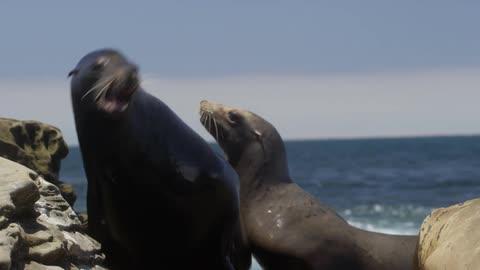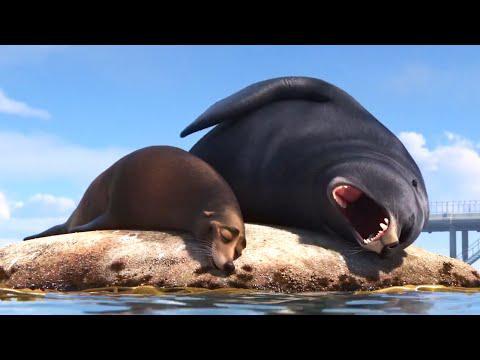The first image is the image on the left, the second image is the image on the right. Evaluate the accuracy of this statement regarding the images: "An image includes a seal in the foreground with its mouth open and head upside-down.". Is it true? Answer yes or no. Yes. The first image is the image on the left, the second image is the image on the right. Considering the images on both sides, is "There are more seals in the image on the right." valid? Answer yes or no. No. 